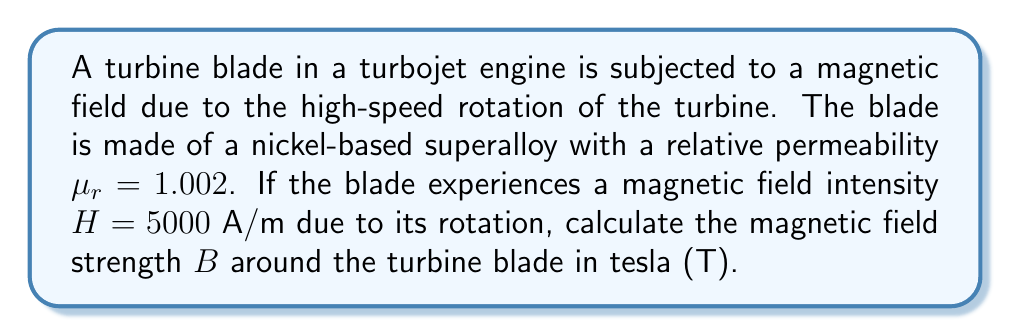Help me with this question. To solve this problem, we'll follow these steps:

1) Recall the relationship between magnetic field strength $B$, magnetic field intensity $H$, and relative permeability $\mu_r$:

   $$B = \mu H$$

   Where $\mu = \mu_0 \mu_r$, and $\mu_0$ is the permeability of free space.

2) We know that $\mu_0 = 4\pi \times 10^{-7} \text{ T}\cdot\text{m}/\text{A}$

3) Calculate $\mu$:
   $$\mu = \mu_0 \mu_r = (4\pi \times 10^{-7})(1.002) = 4.008\pi \times 10^{-7} \text{ T}\cdot\text{m}/\text{A}$$

4) Now we can calculate $B$:
   $$B = \mu H = (4.008\pi \times 10^{-7})(5000)$$

5) Simplify:
   $$B = 2.004\pi \times 10^{-3} \text{ T} \approx 6.29 \times 10^{-3} \text{ T}$$
Answer: $6.29 \times 10^{-3} \text{ T}$ 